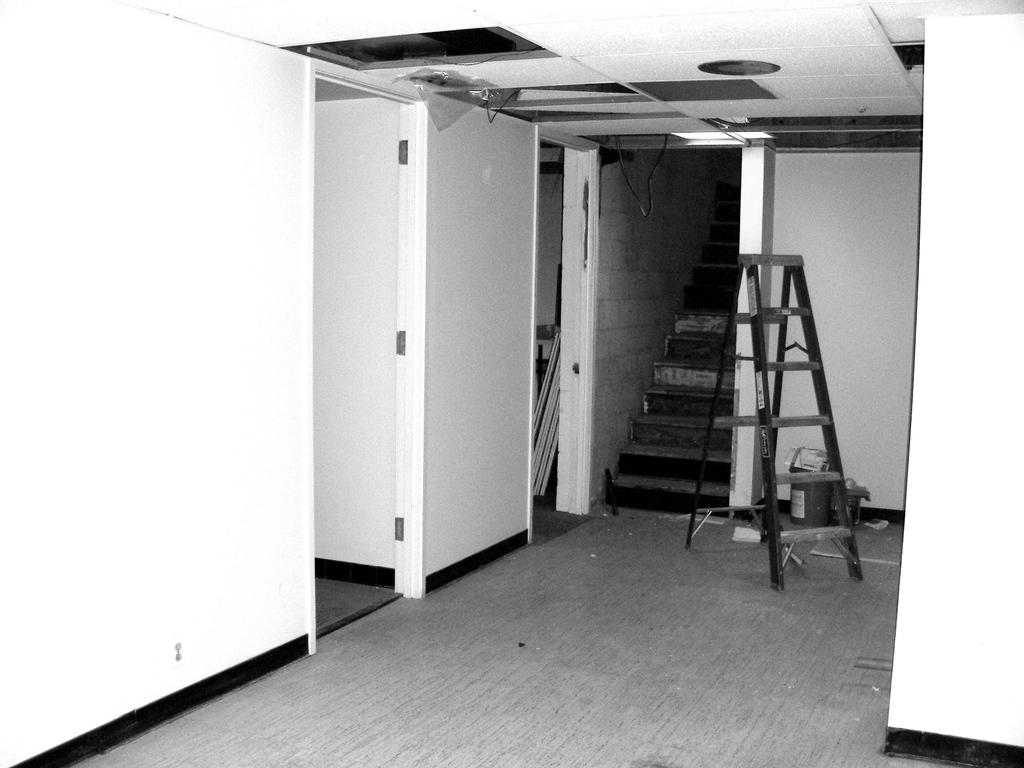What type of location is depicted in the image? The image shows an inside view of a building. What is placed on the floor in the image? There is a ladder on the floor, as well as other unspecified items. What architectural feature can be seen in the background of the image? There are steps visible in the background. How many cats are sitting on the steps in the background of the image? There are no cats present in the image; it only shows a ladder on the floor and steps in the background. 